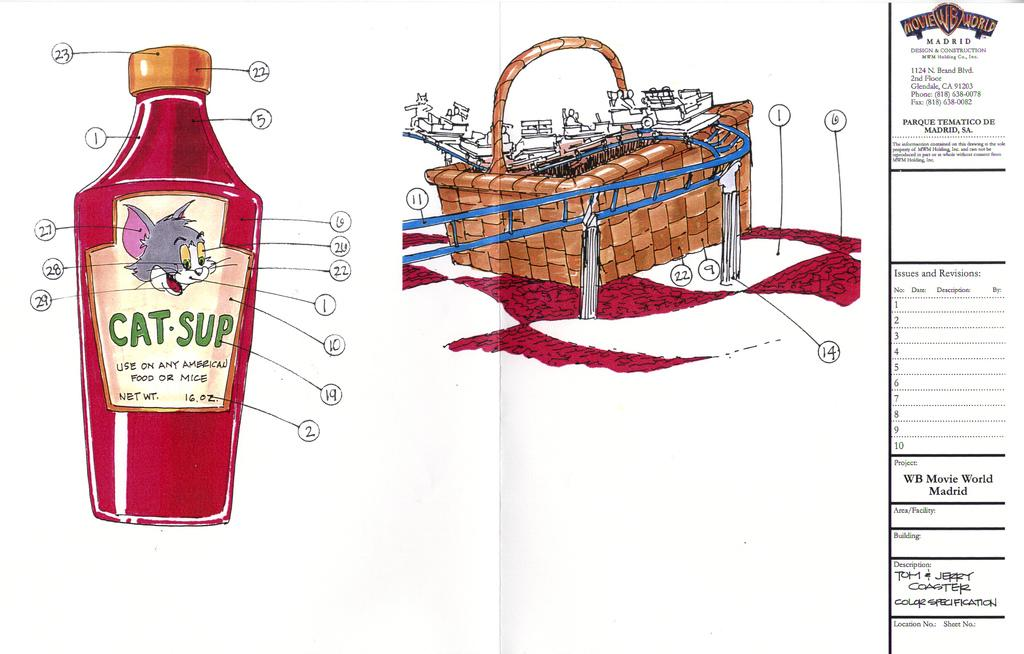Provide a one-sentence caption for the provided image. Drawing of a design that shots CatSup and a cartoon on it. 